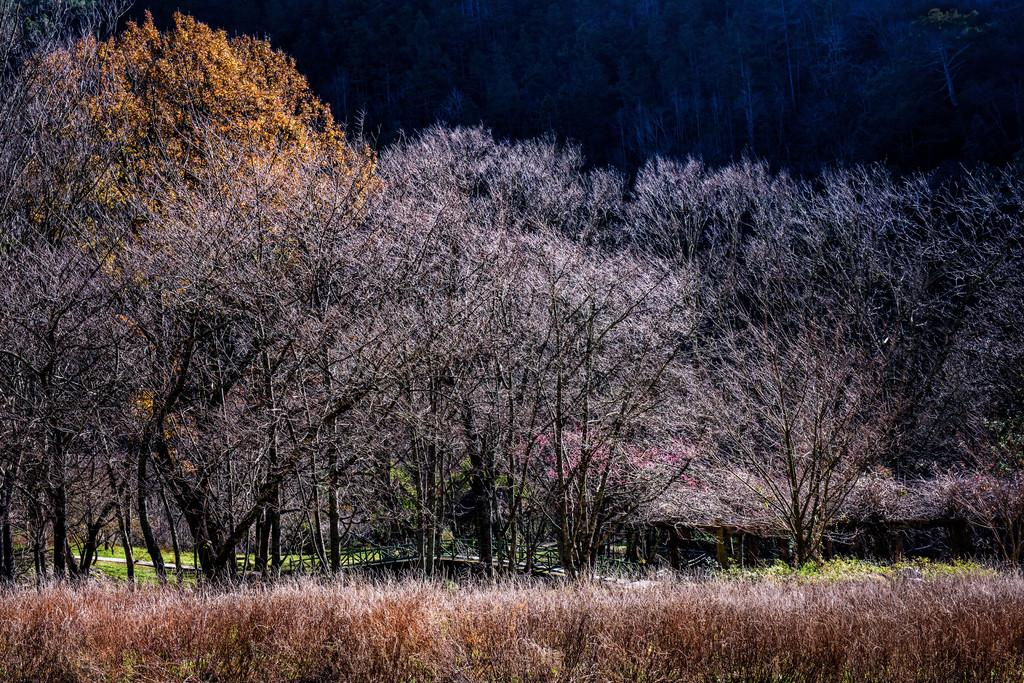What type of natural elements can be seen in the image? There are trees in the image. What colors are the trees in the image? The trees are in white and red color. Where is the drawer located in the image? There is no drawer present in the image; it only features trees in white and red color. 